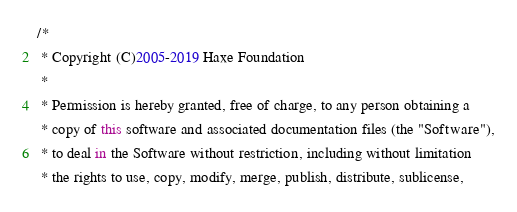<code> <loc_0><loc_0><loc_500><loc_500><_Haxe_>/*
 * Copyright (C)2005-2019 Haxe Foundation
 *
 * Permission is hereby granted, free of charge, to any person obtaining a
 * copy of this software and associated documentation files (the "Software"),
 * to deal in the Software without restriction, including without limitation
 * the rights to use, copy, modify, merge, publish, distribute, sublicense,</code> 